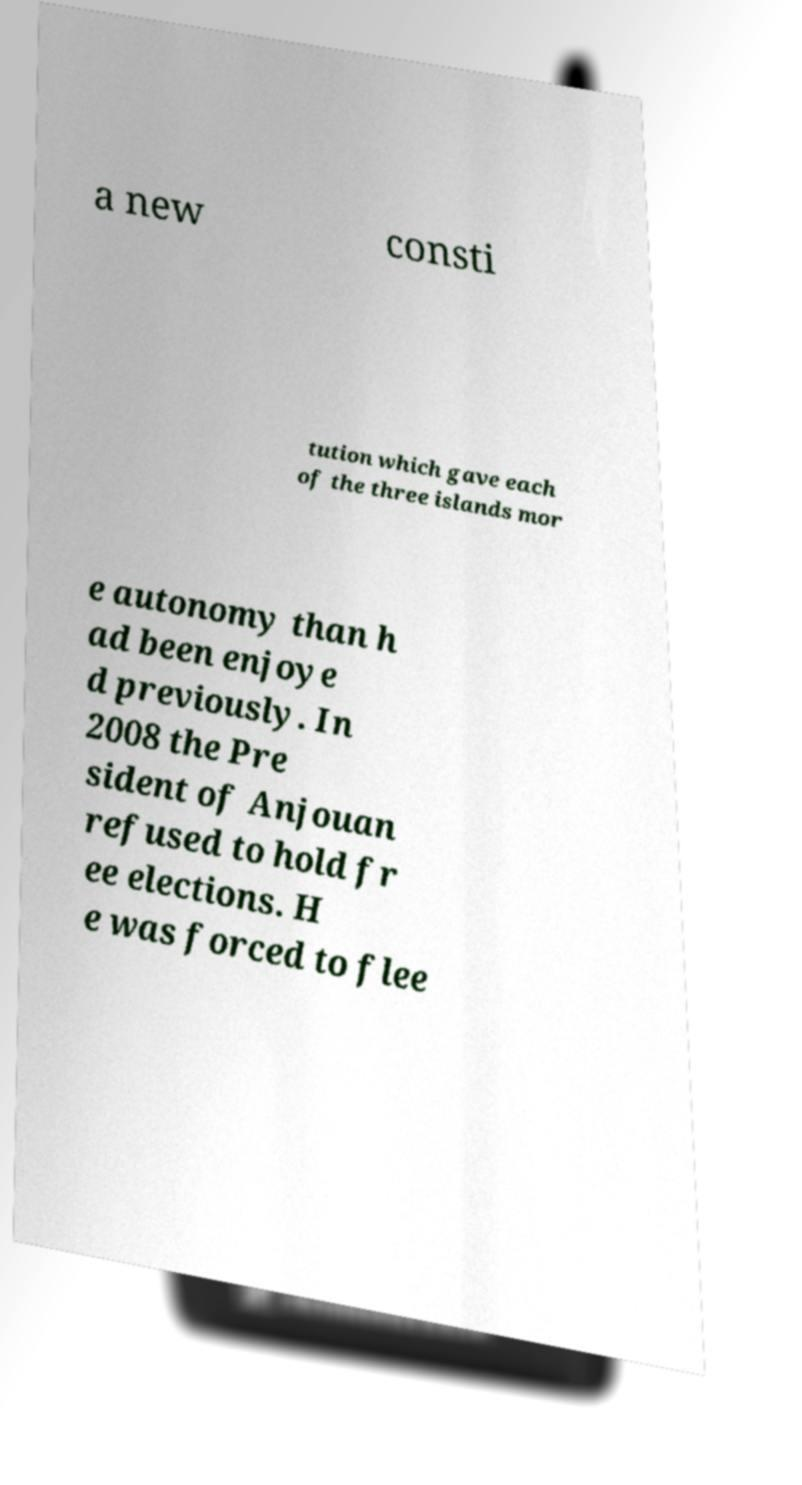Please read and relay the text visible in this image. What does it say? a new consti tution which gave each of the three islands mor e autonomy than h ad been enjoye d previously. In 2008 the Pre sident of Anjouan refused to hold fr ee elections. H e was forced to flee 